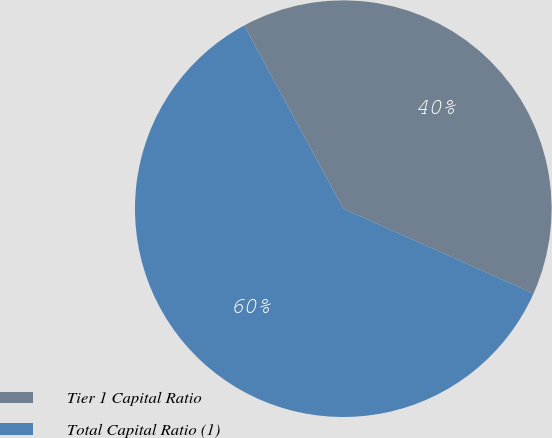Convert chart. <chart><loc_0><loc_0><loc_500><loc_500><pie_chart><fcel>Tier 1 Capital Ratio<fcel>Total Capital Ratio (1)<nl><fcel>39.57%<fcel>60.43%<nl></chart> 